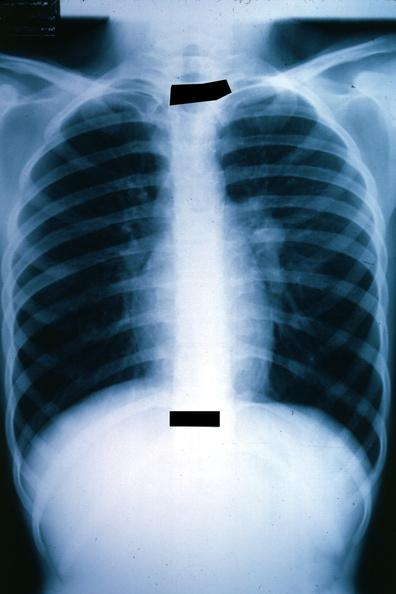does the excellent uterus show x-ray chest well shown left hilar mass tumor in hilar node?
Answer the question using a single word or phrase. No 